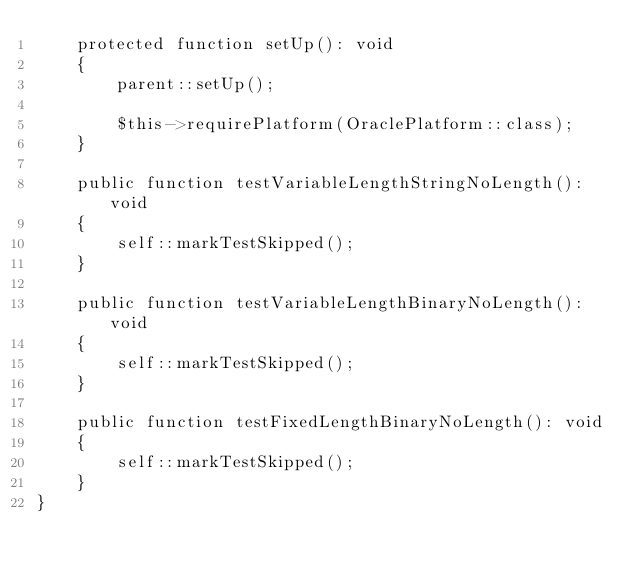Convert code to text. <code><loc_0><loc_0><loc_500><loc_500><_PHP_>    protected function setUp(): void
    {
        parent::setUp();

        $this->requirePlatform(OraclePlatform::class);
    }

    public function testVariableLengthStringNoLength(): void
    {
        self::markTestSkipped();
    }

    public function testVariableLengthBinaryNoLength(): void
    {
        self::markTestSkipped();
    }

    public function testFixedLengthBinaryNoLength(): void
    {
        self::markTestSkipped();
    }
}
</code> 